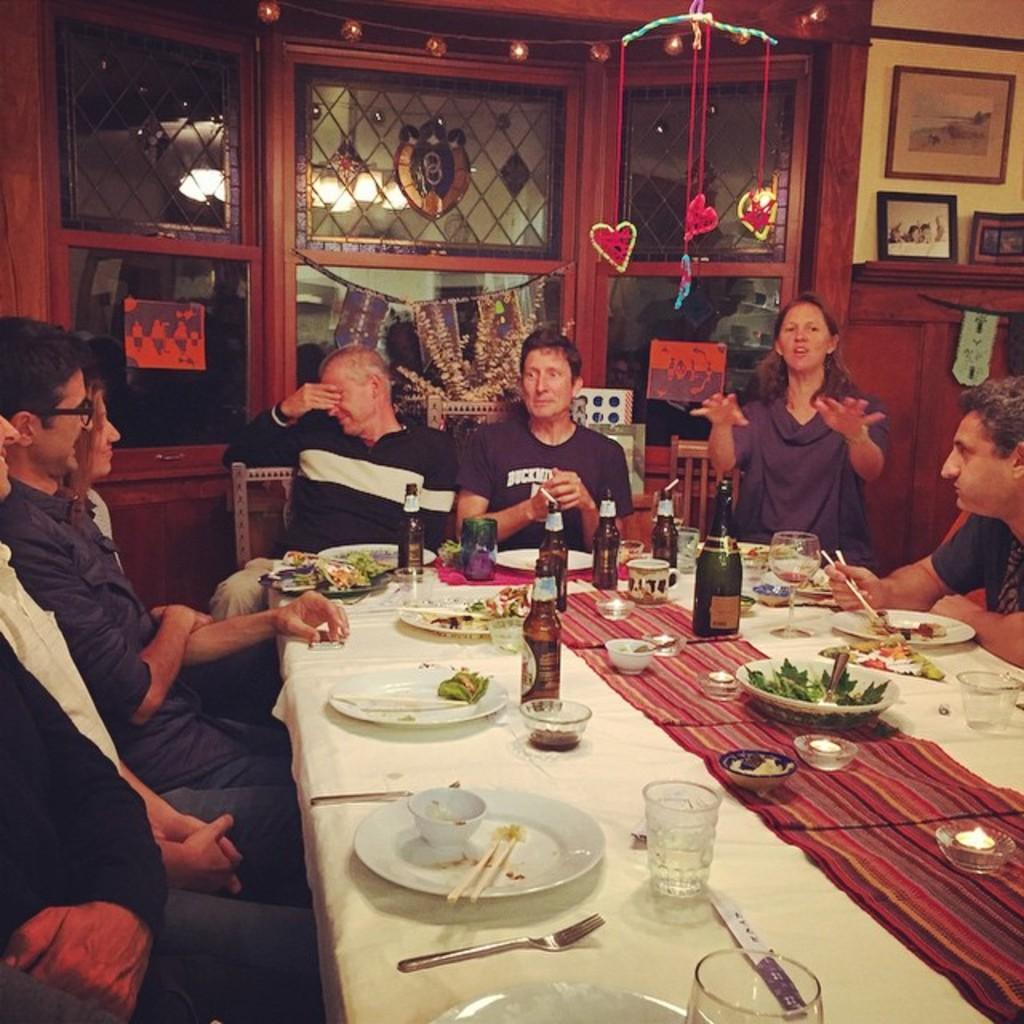Please provide a concise description of this image. In this image there are people sitting on the chairs at the table. There is a cloth spread on the table. On the table there are plates, bowls, glasses, bottles, food and chopsticks. Behind them there are glass windows to the wall. There are decorative things hanging to the ceiling. To the right there is a cupboard. There are picture frames on the cupboard. In the top right there is a picture frame hanging on the wall. 